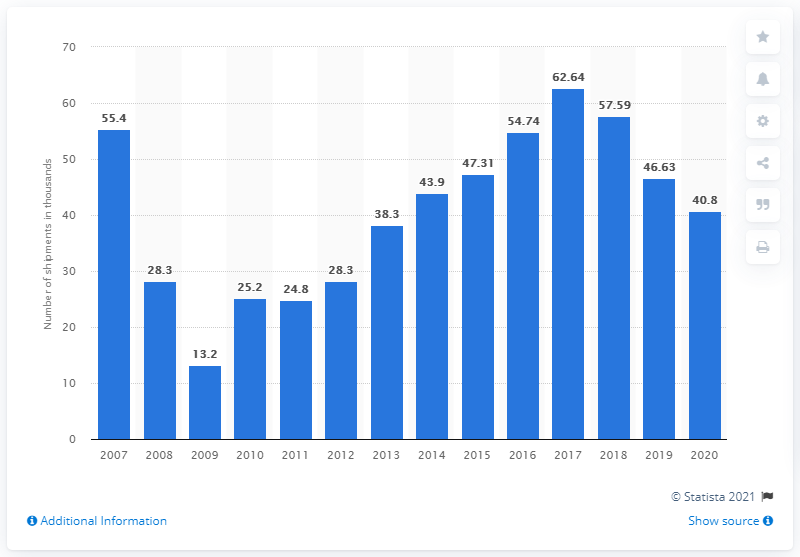List a handful of essential elements in this visual. In 2020, a total of 40,800 motorhomes were shipped from manufacturers to dealers in the United States. 